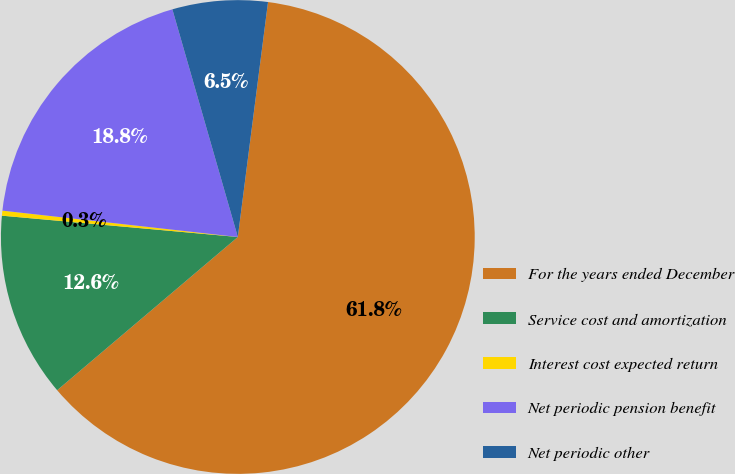Convert chart. <chart><loc_0><loc_0><loc_500><loc_500><pie_chart><fcel>For the years ended December<fcel>Service cost and amortization<fcel>Interest cost expected return<fcel>Net periodic pension benefit<fcel>Net periodic other<nl><fcel>61.77%<fcel>12.63%<fcel>0.34%<fcel>18.77%<fcel>6.49%<nl></chart> 